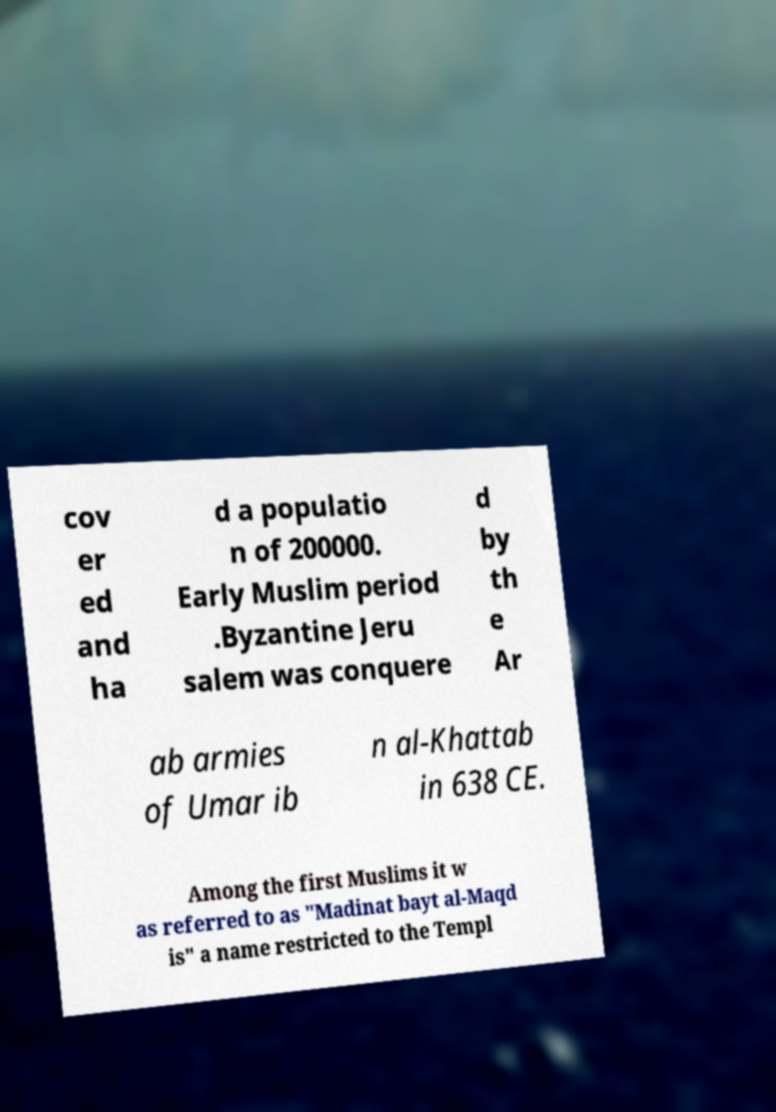What messages or text are displayed in this image? I need them in a readable, typed format. cov er ed and ha d a populatio n of 200000. Early Muslim period .Byzantine Jeru salem was conquere d by th e Ar ab armies of Umar ib n al-Khattab in 638 CE. Among the first Muslims it w as referred to as "Madinat bayt al-Maqd is" a name restricted to the Templ 